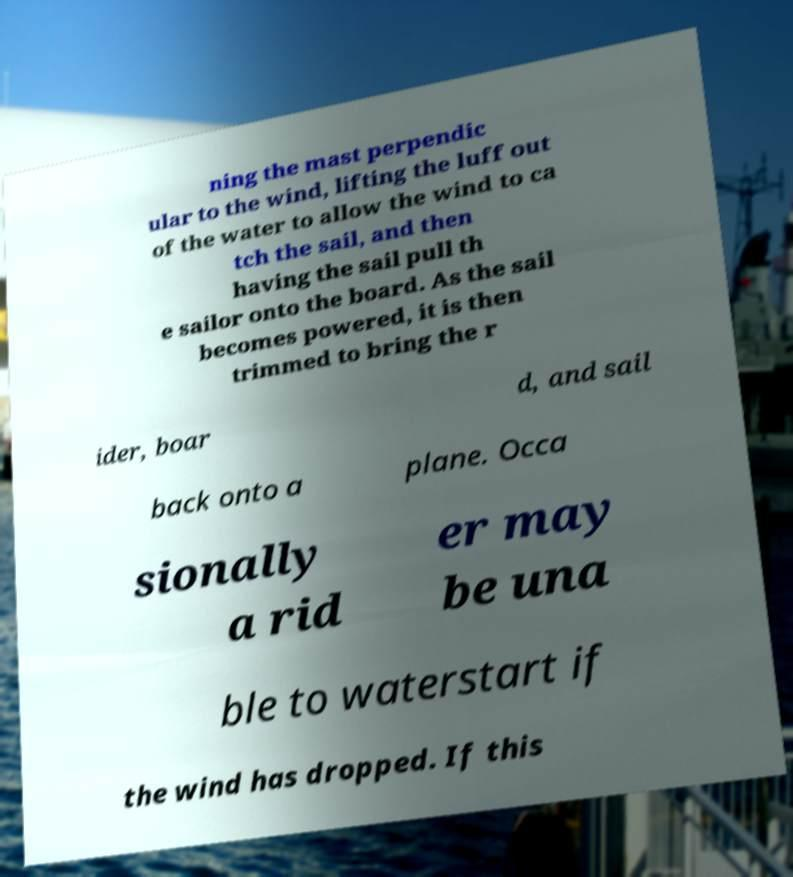Please identify and transcribe the text found in this image. ning the mast perpendic ular to the wind, lifting the luff out of the water to allow the wind to ca tch the sail, and then having the sail pull th e sailor onto the board. As the sail becomes powered, it is then trimmed to bring the r ider, boar d, and sail back onto a plane. Occa sionally a rid er may be una ble to waterstart if the wind has dropped. If this 